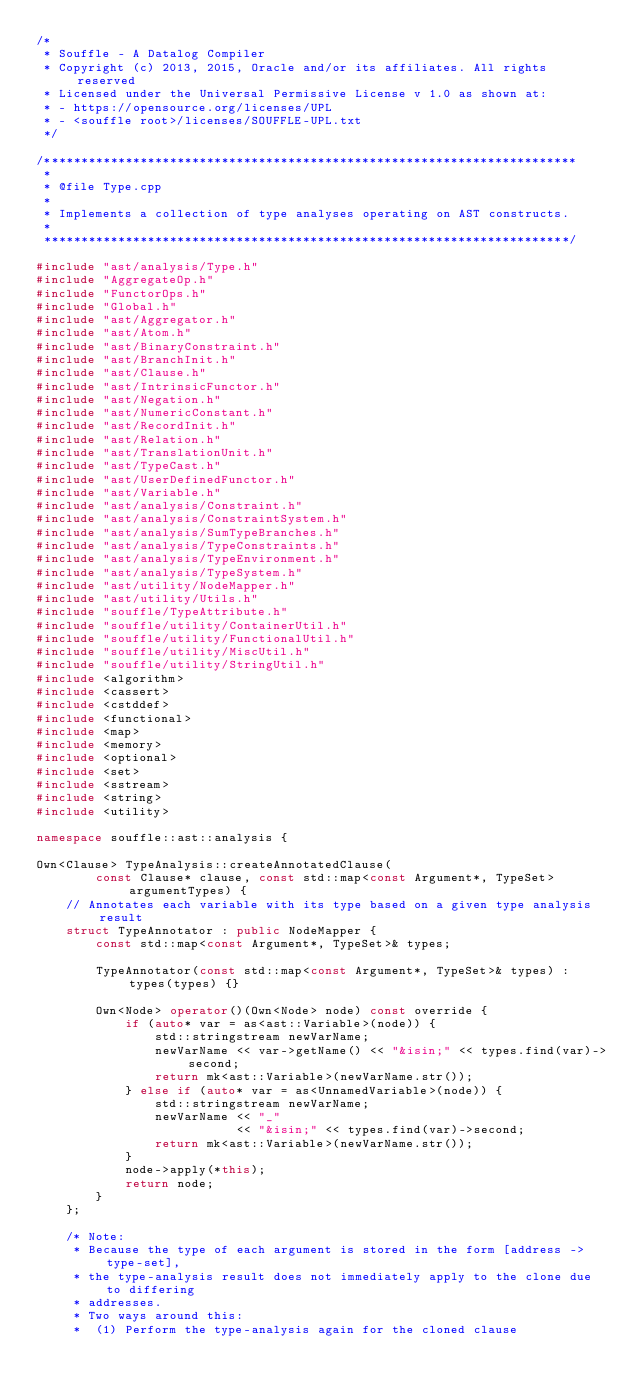<code> <loc_0><loc_0><loc_500><loc_500><_C++_>/*
 * Souffle - A Datalog Compiler
 * Copyright (c) 2013, 2015, Oracle and/or its affiliates. All rights reserved
 * Licensed under the Universal Permissive License v 1.0 as shown at:
 * - https://opensource.org/licenses/UPL
 * - <souffle root>/licenses/SOUFFLE-UPL.txt
 */

/************************************************************************
 *
 * @file Type.cpp
 *
 * Implements a collection of type analyses operating on AST constructs.
 *
 ***********************************************************************/

#include "ast/analysis/Type.h"
#include "AggregateOp.h"
#include "FunctorOps.h"
#include "Global.h"
#include "ast/Aggregator.h"
#include "ast/Atom.h"
#include "ast/BinaryConstraint.h"
#include "ast/BranchInit.h"
#include "ast/Clause.h"
#include "ast/IntrinsicFunctor.h"
#include "ast/Negation.h"
#include "ast/NumericConstant.h"
#include "ast/RecordInit.h"
#include "ast/Relation.h"
#include "ast/TranslationUnit.h"
#include "ast/TypeCast.h"
#include "ast/UserDefinedFunctor.h"
#include "ast/Variable.h"
#include "ast/analysis/Constraint.h"
#include "ast/analysis/ConstraintSystem.h"
#include "ast/analysis/SumTypeBranches.h"
#include "ast/analysis/TypeConstraints.h"
#include "ast/analysis/TypeEnvironment.h"
#include "ast/analysis/TypeSystem.h"
#include "ast/utility/NodeMapper.h"
#include "ast/utility/Utils.h"
#include "souffle/TypeAttribute.h"
#include "souffle/utility/ContainerUtil.h"
#include "souffle/utility/FunctionalUtil.h"
#include "souffle/utility/MiscUtil.h"
#include "souffle/utility/StringUtil.h"
#include <algorithm>
#include <cassert>
#include <cstddef>
#include <functional>
#include <map>
#include <memory>
#include <optional>
#include <set>
#include <sstream>
#include <string>
#include <utility>

namespace souffle::ast::analysis {

Own<Clause> TypeAnalysis::createAnnotatedClause(
        const Clause* clause, const std::map<const Argument*, TypeSet> argumentTypes) {
    // Annotates each variable with its type based on a given type analysis result
    struct TypeAnnotator : public NodeMapper {
        const std::map<const Argument*, TypeSet>& types;

        TypeAnnotator(const std::map<const Argument*, TypeSet>& types) : types(types) {}

        Own<Node> operator()(Own<Node> node) const override {
            if (auto* var = as<ast::Variable>(node)) {
                std::stringstream newVarName;
                newVarName << var->getName() << "&isin;" << types.find(var)->second;
                return mk<ast::Variable>(newVarName.str());
            } else if (auto* var = as<UnnamedVariable>(node)) {
                std::stringstream newVarName;
                newVarName << "_"
                           << "&isin;" << types.find(var)->second;
                return mk<ast::Variable>(newVarName.str());
            }
            node->apply(*this);
            return node;
        }
    };

    /* Note:
     * Because the type of each argument is stored in the form [address -> type-set],
     * the type-analysis result does not immediately apply to the clone due to differing
     * addresses.
     * Two ways around this:
     *  (1) Perform the type-analysis again for the cloned clause</code> 